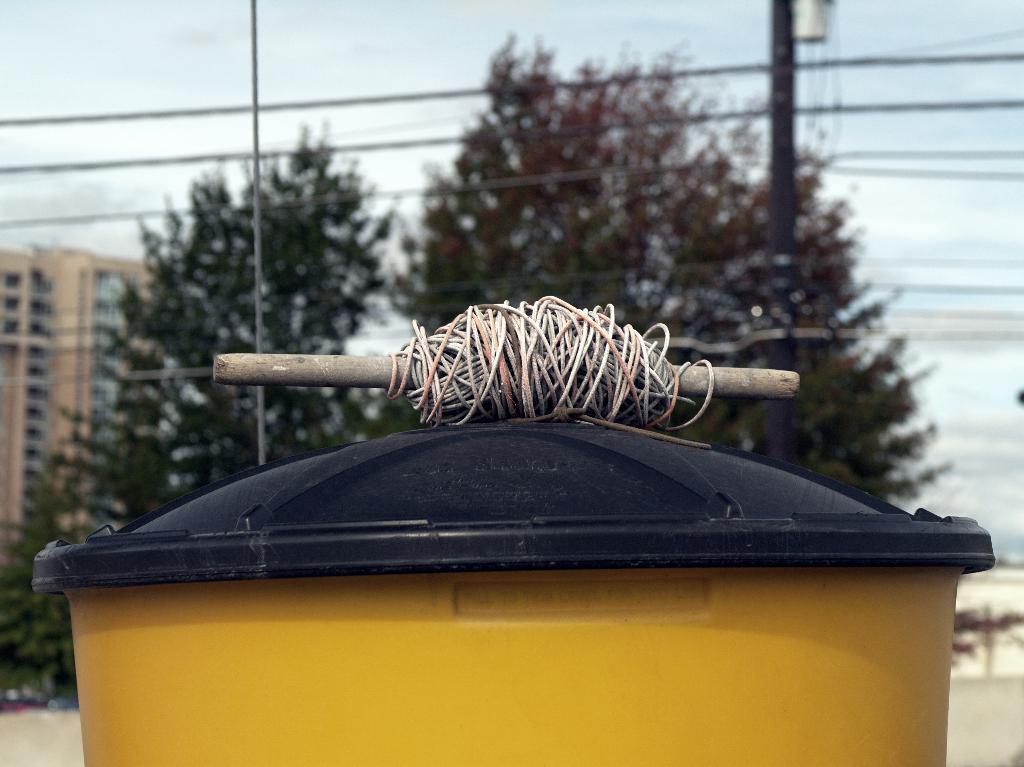In one or two sentences, can you explain what this image depicts? In this image I can see a bin which is yellow and black in color and on it I can see a wooden stick to which a wire is coiled. In the background I can see few trees, a pole which is black in color, few wires, a building and the sky. 